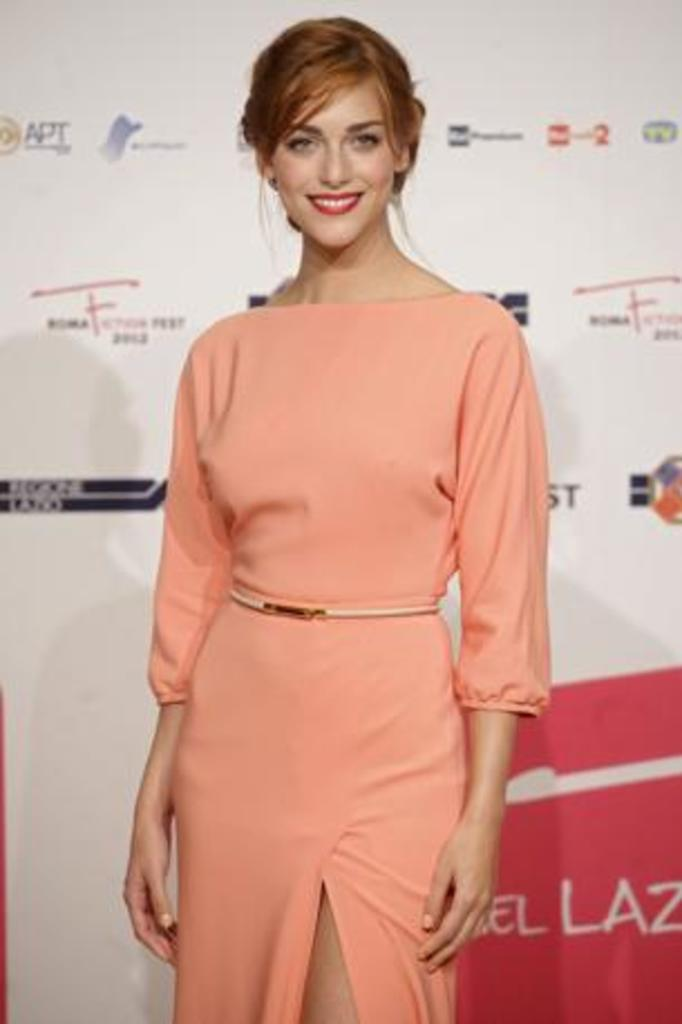Who is the main subject in the image? There is a woman standing in the center of the image. What is the woman doing in the image? The woman is smiling. What can be seen in the background of the image? There is a board in the background of the image. What is written or displayed on the board? The board contains logos and text. Can you see a rose in the woman's hand in the image? There is no rose visible in the woman's hand in the image. What type of drink is the woman holding in the image? The woman is not holding a drink in the image. 